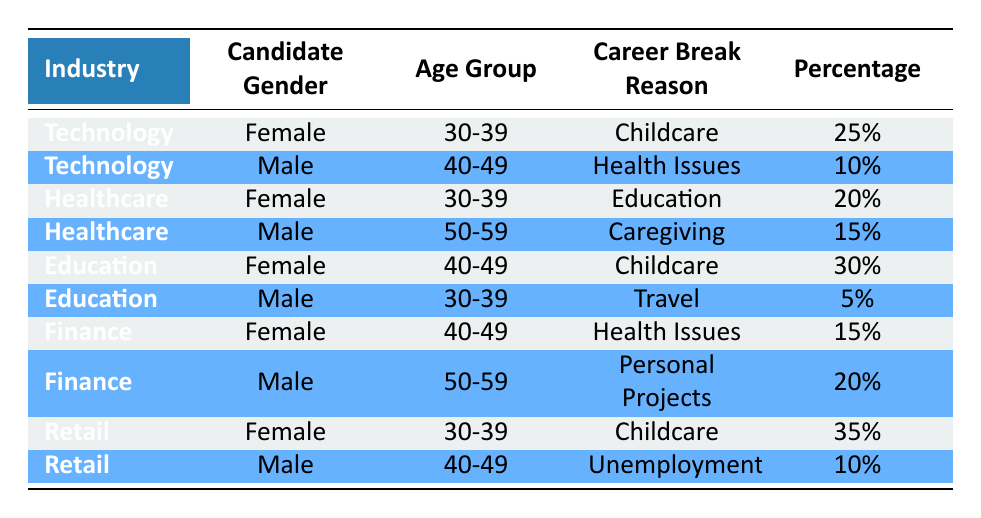What is the most common career break reason for female candidates in the Technology industry? In the Technology industry, the only career break reason listed for female candidates is "Childcare." The percentage for this reason is 25, which indicates it is the most common.
Answer: Childcare Which gender has the highest percentage for the "Health Issues" career break reason in the Finance industry? In the Finance industry, "Health Issues" applies to female candidates with a percentage of 15, and male candidates are not associated with this reason. Thus, females have the highest percentage for this reason.
Answer: Female What is the total percentage of male candidates in the Healthcare and Education industries who took a career break for caregiving or unemployment? In the Healthcare industry, the male candidates' percentage for "Caregiving" is 15. In the Education industry, the male candidates' percentage for "Unemployment" is 10. Summing these gives 15 + 10 = 25.
Answer: 25 Is there any career break reason listed for female candidates in the Retail industry? Yes, there is a career break reason listed for female candidates in the Retail industry, which is "Childcare" with a percentage of 35.
Answer: Yes What age group has the highest percentage of female candidates who took a career break due to Childcare across all industries? In the Technology industry, 25% of female candidates are ages 30-39 for "Childcare." In the Education industry, this percentage is 30, which is higher. In the Retail industry, the percentage is 35, which is the highest among all three. Thus, the age group 30-39 has the highest percentage for female candidates across industries for this reason.
Answer: 30-39 